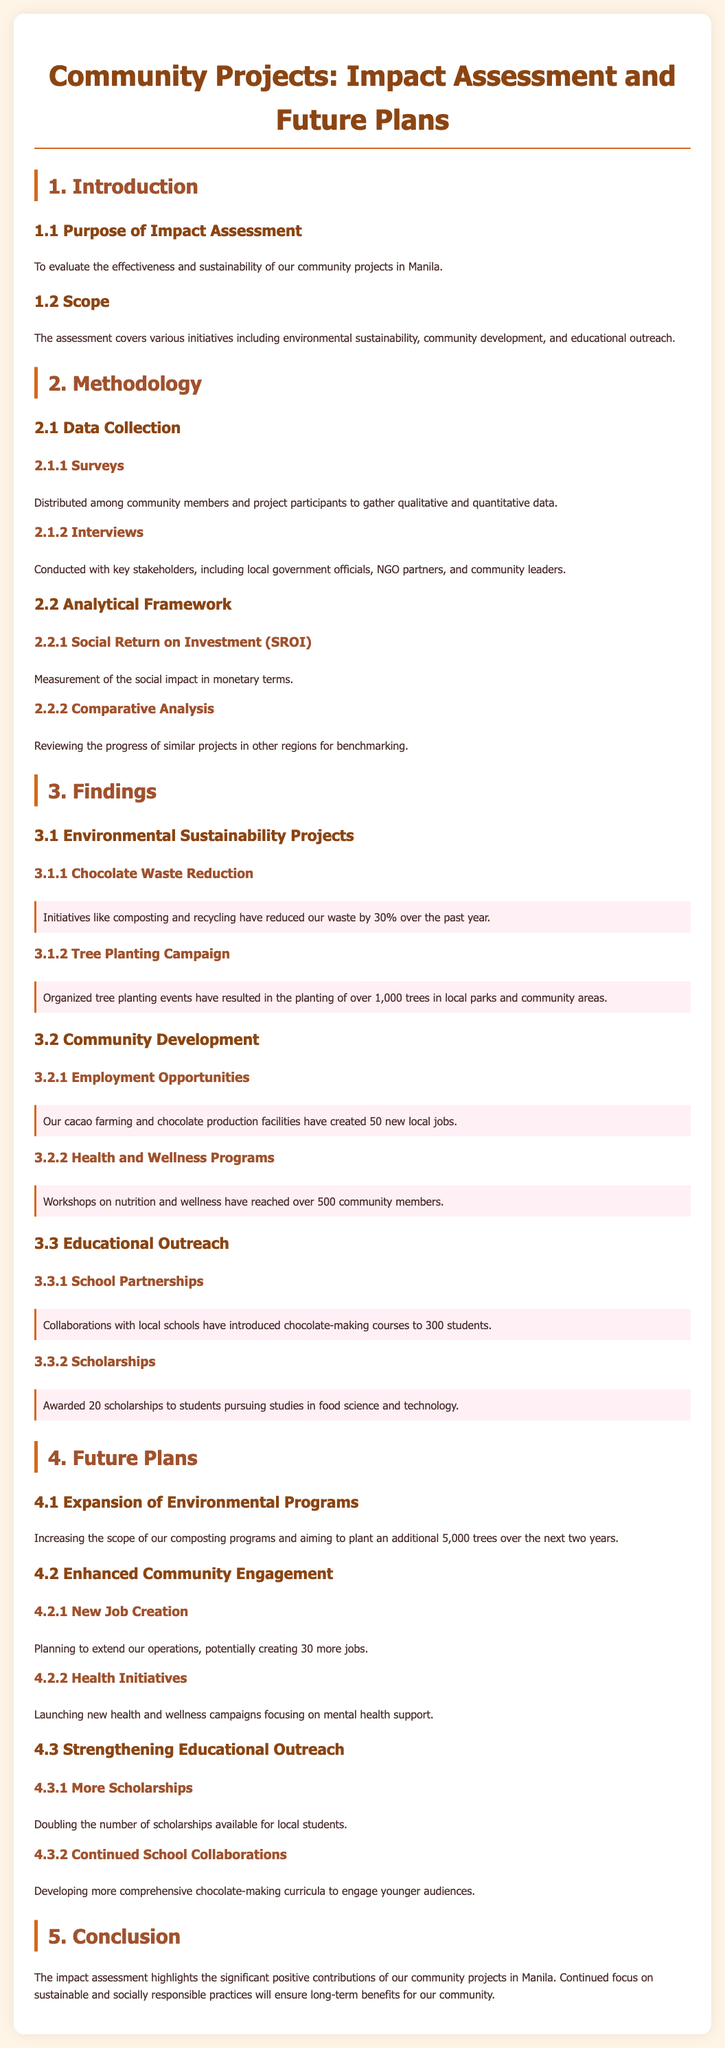What is the main purpose of the impact assessment? The document states that the purpose is to evaluate the effectiveness and sustainability of community projects.
Answer: Evaluate effectiveness and sustainability How many new local jobs were created? The report specifies that 50 new local jobs were created through cacao farming and chocolate production.
Answer: 50 How many scholarships were awarded? The document mentions that 20 scholarships were awarded to students pursuing studies in food science and technology.
Answer: 20 What environmental initiative reduced waste by 30%? The Chocolate Waste Reduction initiative is highlighted as having reduced waste by 30%.
Answer: Chocolate Waste Reduction What is the target number of additional trees to plant in the next two years? The future plans aim to plant an additional 5,000 trees over the next two years.
Answer: 5,000 What framework is used to measure social impact? The document indicates that Social Return on Investment (SROI) is used to measure social impact.
Answer: Social Return on Investment (SROI) Which program reached over 500 community members? The Health and Wellness Programs reached over 500 community members through workshops.
Answer: Health and Wellness Programs What is the focus of the new health initiatives? The focus of the new health initiatives is on mental health support.
Answer: Mental health support 